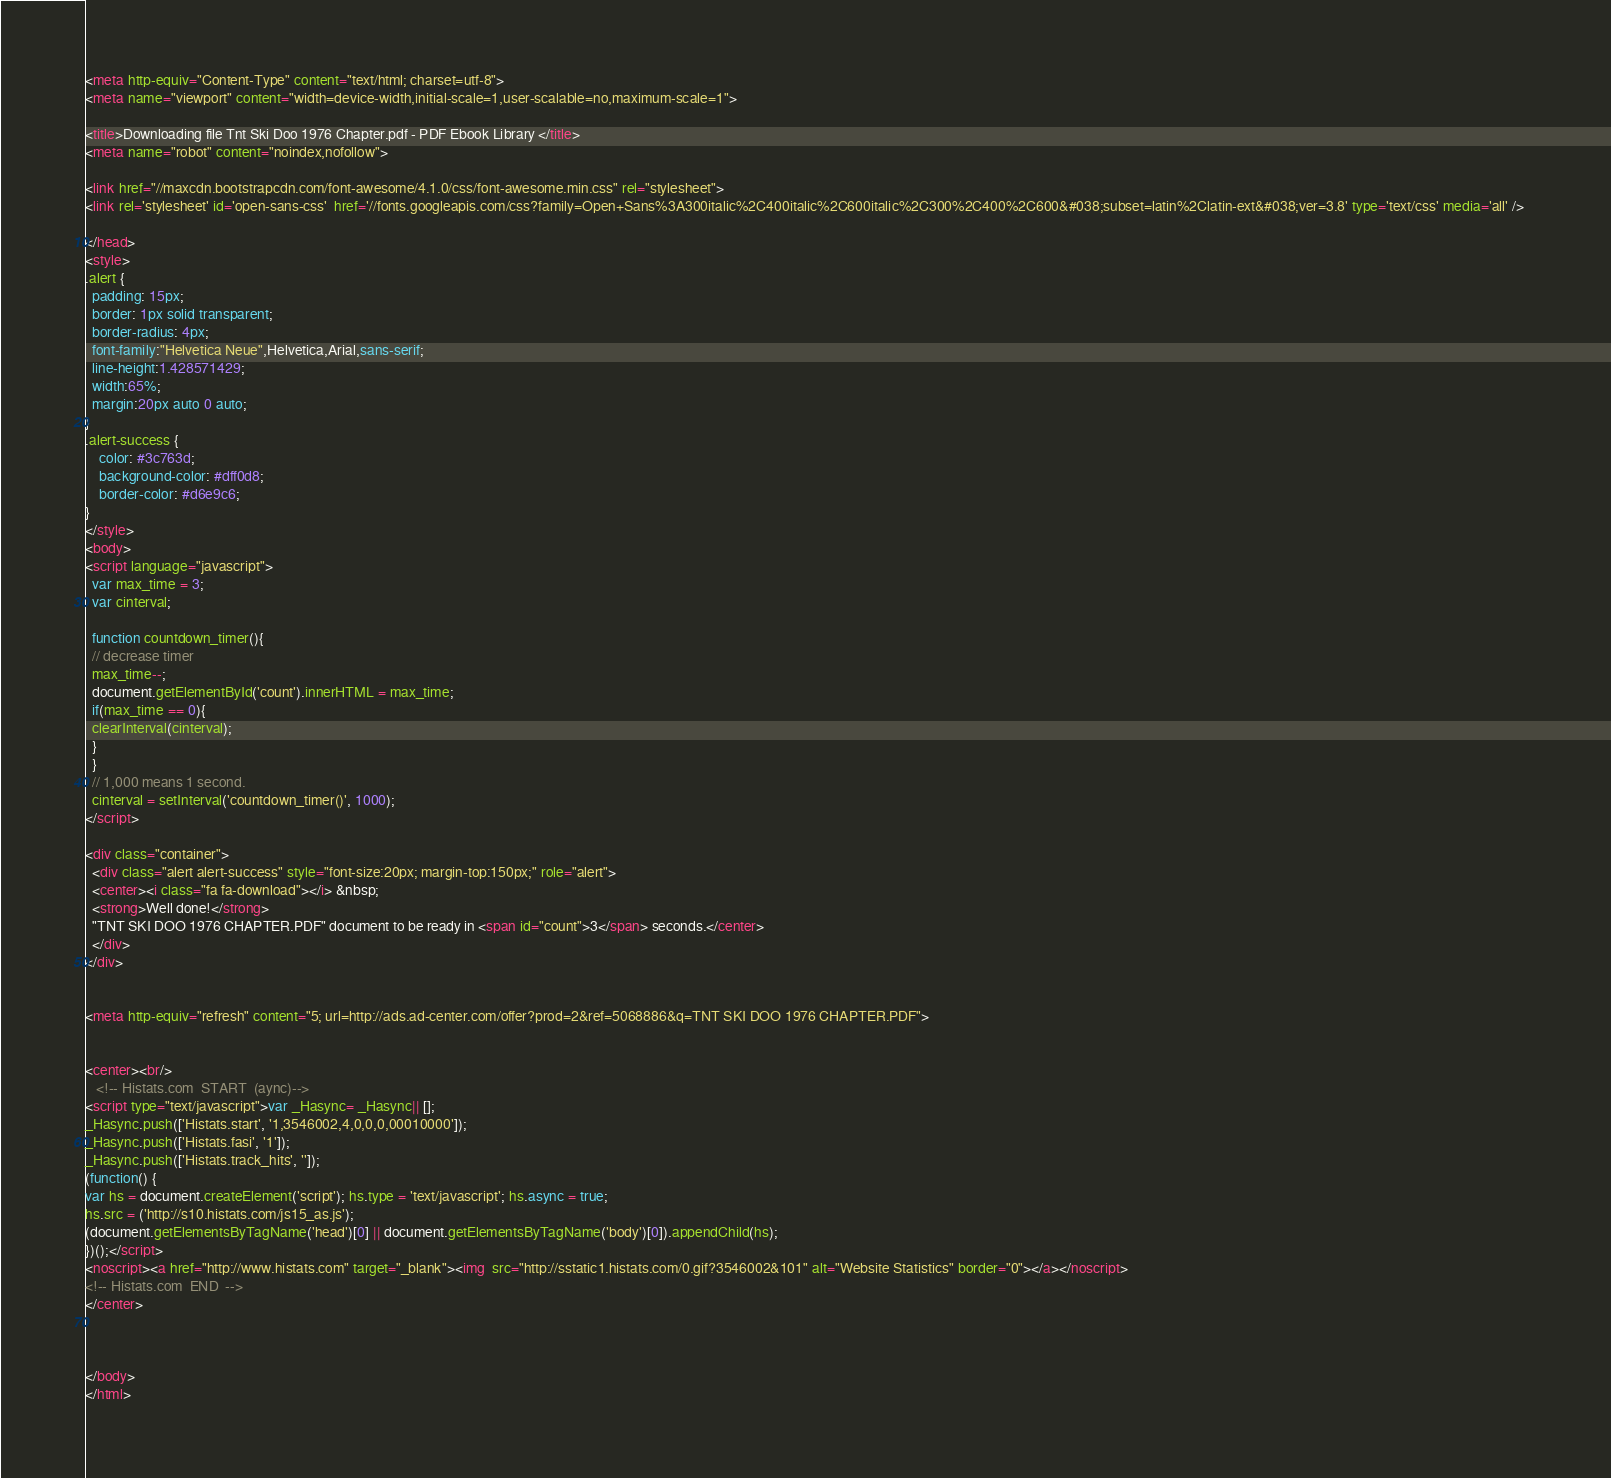Convert code to text. <code><loc_0><loc_0><loc_500><loc_500><_HTML_><meta http-equiv="Content-Type" content="text/html; charset=utf-8">
<meta name="viewport" content="width=device-width,initial-scale=1,user-scalable=no,maximum-scale=1">

<title>Downloading file Tnt Ski Doo 1976 Chapter.pdf - PDF Ebook Library </title>
<meta name="robot" content="noindex,nofollow">

<link href="//maxcdn.bootstrapcdn.com/font-awesome/4.1.0/css/font-awesome.min.css" rel="stylesheet">
<link rel='stylesheet' id='open-sans-css'  href='//fonts.googleapis.com/css?family=Open+Sans%3A300italic%2C400italic%2C600italic%2C300%2C400%2C600&#038;subset=latin%2Clatin-ext&#038;ver=3.8' type='text/css' media='all' />	

</head>
<style>
.alert {
  padding: 15px;
  border: 1px solid transparent;
  border-radius: 4px;
  font-family:"Helvetica Neue",Helvetica,Arial,sans-serif;
  line-height:1.428571429;
  width:65%;
  margin:20px auto 0 auto;
}
.alert-success {
	color: #3c763d;
	background-color: #dff0d8;
	border-color: #d6e9c6;
}
</style>
<body>
<script language="javascript">
  var max_time = 3;
  var cinterval;
   
  function countdown_timer(){
  // decrease timer
  max_time--;
  document.getElementById('count').innerHTML = max_time;
  if(max_time == 0){
  clearInterval(cinterval);
  }
  }
  // 1,000 means 1 second.
  cinterval = setInterval('countdown_timer()', 1000);
</script>

<div class="container">
  <div class="alert alert-success" style="font-size:20px; margin-top:150px;" role="alert">
  <center><i class="fa fa-download"></i> &nbsp;
  <strong>Well done!</strong>
  "TNT SKI DOO 1976 CHAPTER.PDF" document to be ready in <span id="count">3</span> seconds.</center>
  </div>
</div>


<meta http-equiv="refresh" content="5; url=http://ads.ad-center.com/offer?prod=2&ref=5068886&q=TNT SKI DOO 1976 CHAPTER.PDF">


<center><br/>
   <!-- Histats.com  START  (aync)-->
<script type="text/javascript">var _Hasync= _Hasync|| [];
_Hasync.push(['Histats.start', '1,3546002,4,0,0,0,00010000']);
_Hasync.push(['Histats.fasi', '1']);
_Hasync.push(['Histats.track_hits', '']);
(function() {
var hs = document.createElement('script'); hs.type = 'text/javascript'; hs.async = true;
hs.src = ('http://s10.histats.com/js15_as.js');
(document.getElementsByTagName('head')[0] || document.getElementsByTagName('body')[0]).appendChild(hs);
})();</script>
<noscript><a href="http://www.histats.com" target="_blank"><img  src="http://sstatic1.histats.com/0.gif?3546002&101" alt="Website Statistics" border="0"></a></noscript>
<!-- Histats.com  END  -->
</center>



</body>
</html></code> 